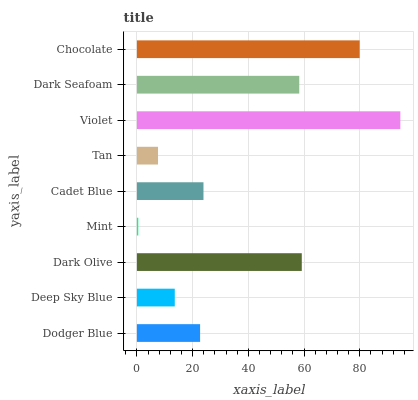Is Mint the minimum?
Answer yes or no. Yes. Is Violet the maximum?
Answer yes or no. Yes. Is Deep Sky Blue the minimum?
Answer yes or no. No. Is Deep Sky Blue the maximum?
Answer yes or no. No. Is Dodger Blue greater than Deep Sky Blue?
Answer yes or no. Yes. Is Deep Sky Blue less than Dodger Blue?
Answer yes or no. Yes. Is Deep Sky Blue greater than Dodger Blue?
Answer yes or no. No. Is Dodger Blue less than Deep Sky Blue?
Answer yes or no. No. Is Cadet Blue the high median?
Answer yes or no. Yes. Is Cadet Blue the low median?
Answer yes or no. Yes. Is Dark Seafoam the high median?
Answer yes or no. No. Is Dodger Blue the low median?
Answer yes or no. No. 